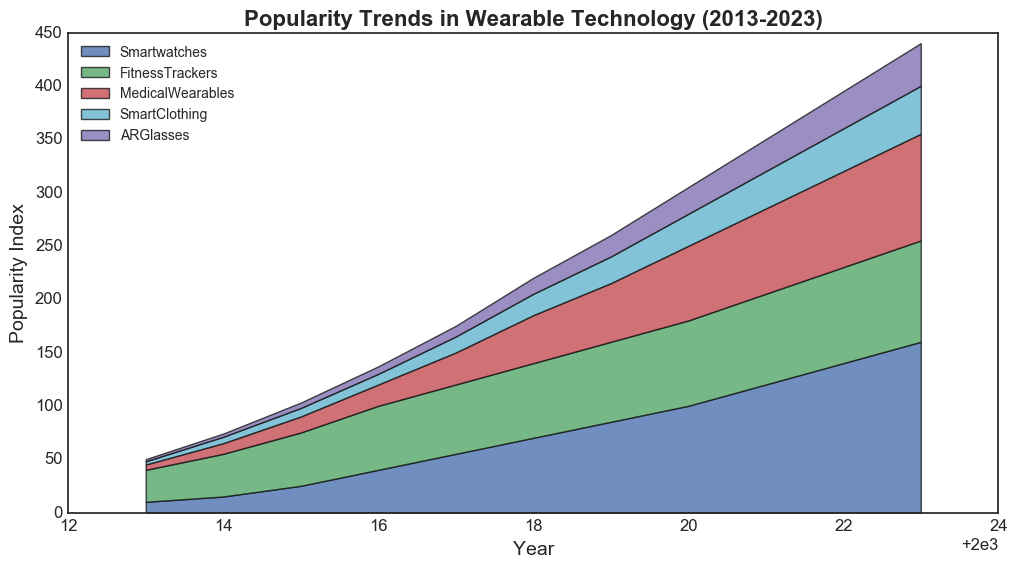What's the most popular wearable technology in 2023? The figure shows the popularity trends of various wearable technologies over the years. By looking at the rightmost point in the chart (2023), the area for Smartwatches is the highest among all categories.
Answer: Smartwatches How did the popularity of Fitness Trackers change from 2016 to 2020? To find this, look at the heights of the Fitness Trackers area in the years 2016 and 2020. The popularity index was 60 in 2016 and increased to 80 in 2020, resulting in a change of 20 units.
Answer: Increased by 20 Which type of wearable had the highest growth rate in popularity from 2013 to 2023? By examining the area changes from 2013 to 2023 for each category, Smartwatches increased from 10 to 160, Fitness Trackers from 30 to 95, Medical Wearables from 5 to 100, Smart Clothing from 3 to 45, and AR Glasses from 2 to 40. The highest growth rate is thus observed in Smartwatches, growing by 150 units.
Answer: Smartwatches What is the total popularity index for all wearables combined in 2020? Sum the popularity indices for each type of wearable in 2020. Smartwatches: 100, Fitness Trackers: 80, Medical Wearables: 70, Smart Clothing: 30, AR Glasses: 25. Sum = 100 + 80 + 70 + 30 + 25 = 305.
Answer: 305 In which year did Medical Wearables surpass Fitness Trackers in popularity? Medical Wearables never surpassed Fitness Trackers in popularity throughout the examined years. By evaluating the trend, Fitness Trackers consistently had a higher popularity index than Medical Wearables.
Answer: Never Which category shows the most steady growth without any declines or plateaus? Observing each area for consistency, Smartwatches exhibit steady growth from 2013 to 2023 with no declines or plateaus in their popularity index.
Answer: Smartwatches How many categories had a popularity index of 50 or more in 2019? The categories with indices of 50 or more in 2019 can be pinpointed by examining the height: Smartwatches (85), Fitness Trackers (75), Medical Wearables (55). Hence, three categories met the criterion.
Answer: 3 If the AR Glasses and Smart Clothing categories were combined, what would their total popularity be in 2023? Add the popularity indices of AR Glasses (40) and Smart Clothing (45) in 2023. Total = 40 + 45 = 85.
Answer: 85 Compare the average annual growth in popularity between Smartwatches and Fitness Trackers from 2013 to 2023. Smartwatches grew from 10 to 160 over 10 years, resulting in an increase of 150 units, which gives an average annual growth of 150/10 = 15 units per year. Fitness Trackers grew from 30 to 95 over 10 years, with an increase of 65 units, resulting in an average annual growth of 65/10 = 6.5 units per year.
Answer: Smartwatches: 15 units/year, Fitness Trackers: 6.5 units/year 